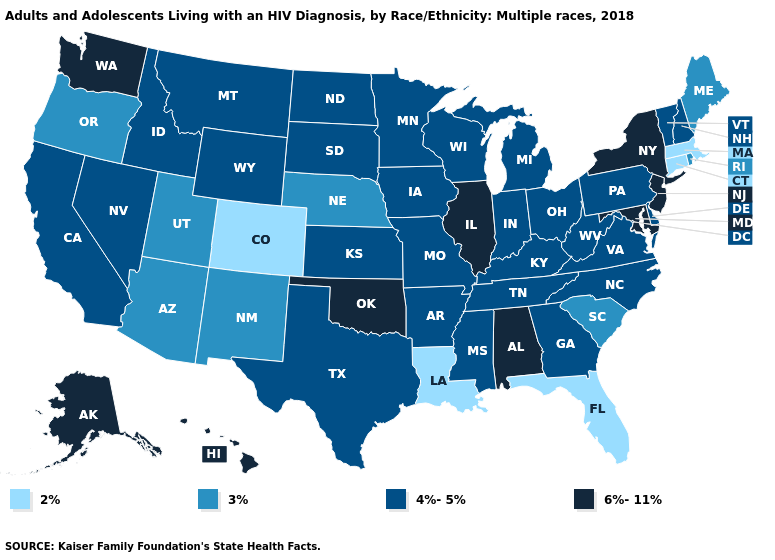Does the map have missing data?
Short answer required. No. What is the value of Colorado?
Quick response, please. 2%. What is the value of Nevada?
Concise answer only. 4%-5%. How many symbols are there in the legend?
Write a very short answer. 4. Is the legend a continuous bar?
Short answer required. No. Does Florida have the lowest value in the USA?
Be succinct. Yes. What is the value of Maryland?
Write a very short answer. 6%-11%. Name the states that have a value in the range 4%-5%?
Keep it brief. Arkansas, California, Delaware, Georgia, Idaho, Indiana, Iowa, Kansas, Kentucky, Michigan, Minnesota, Mississippi, Missouri, Montana, Nevada, New Hampshire, North Carolina, North Dakota, Ohio, Pennsylvania, South Dakota, Tennessee, Texas, Vermont, Virginia, West Virginia, Wisconsin, Wyoming. What is the value of Delaware?
Be succinct. 4%-5%. Name the states that have a value in the range 2%?
Write a very short answer. Colorado, Connecticut, Florida, Louisiana, Massachusetts. What is the value of West Virginia?
Give a very brief answer. 4%-5%. Name the states that have a value in the range 2%?
Quick response, please. Colorado, Connecticut, Florida, Louisiana, Massachusetts. Name the states that have a value in the range 6%-11%?
Give a very brief answer. Alabama, Alaska, Hawaii, Illinois, Maryland, New Jersey, New York, Oklahoma, Washington. Does the map have missing data?
Answer briefly. No. 